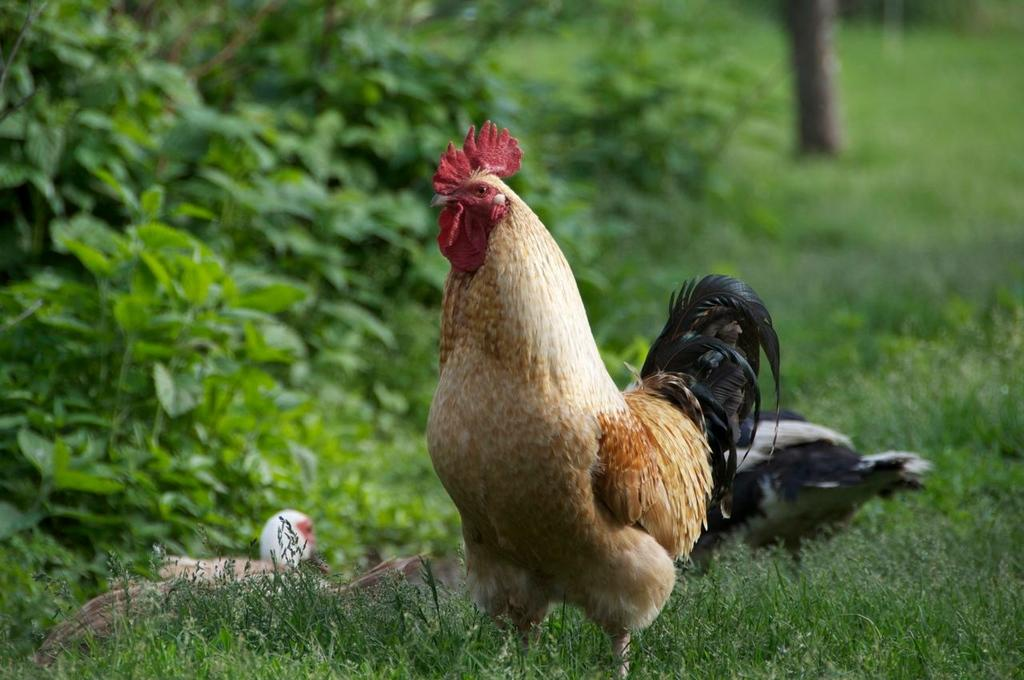What type of vegetation is visible in the image? There is grass in the image. What other type of vegetation can be seen in the image? There are plants in the image. What animals are present in the image? There are hens in the image. Where is the plantation located in the image? There is no plantation present in the image. Can you see any fairies interacting with the hens in the image? There are no fairies present in the image. What type of furniture is visible in the image? There is no furniture, such as a chair, present in the image. 